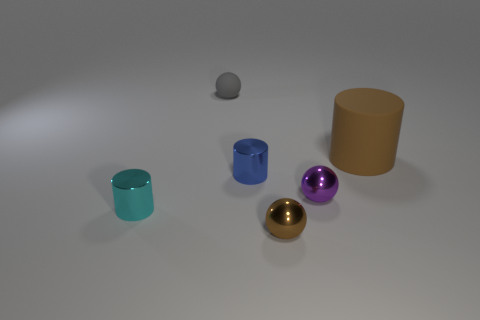There is a shiny object in front of the small cyan metal cylinder; is its size the same as the matte object to the left of the purple object?
Your response must be concise. Yes. There is a brown object behind the tiny object left of the tiny matte ball; what shape is it?
Your answer should be very brief. Cylinder. What number of metal things are right of the cyan metallic cylinder?
Keep it short and to the point. 3. The other cylinder that is made of the same material as the tiny blue cylinder is what color?
Offer a very short reply. Cyan. There is a brown sphere; is its size the same as the shiny sphere that is behind the tiny cyan shiny cylinder?
Your answer should be very brief. Yes. There is a brown object that is behind the tiny shiny cylinder that is to the left of the object behind the large matte cylinder; what size is it?
Your answer should be very brief. Large. How many matte objects are tiny brown things or tiny purple spheres?
Give a very brief answer. 0. What is the color of the rubber object right of the gray rubber object?
Offer a very short reply. Brown. There is a purple metallic thing that is the same size as the gray rubber sphere; what shape is it?
Offer a very short reply. Sphere. Does the large cylinder have the same color as the small sphere in front of the small cyan shiny thing?
Ensure brevity in your answer.  Yes. 